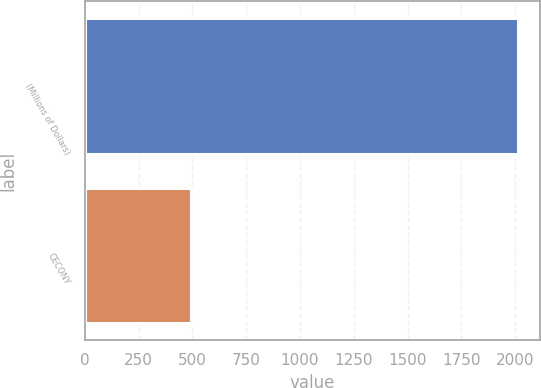Convert chart to OTSL. <chart><loc_0><loc_0><loc_500><loc_500><bar_chart><fcel>(Millions of Dollars)<fcel>CECONY<nl><fcel>2012<fcel>492<nl></chart> 